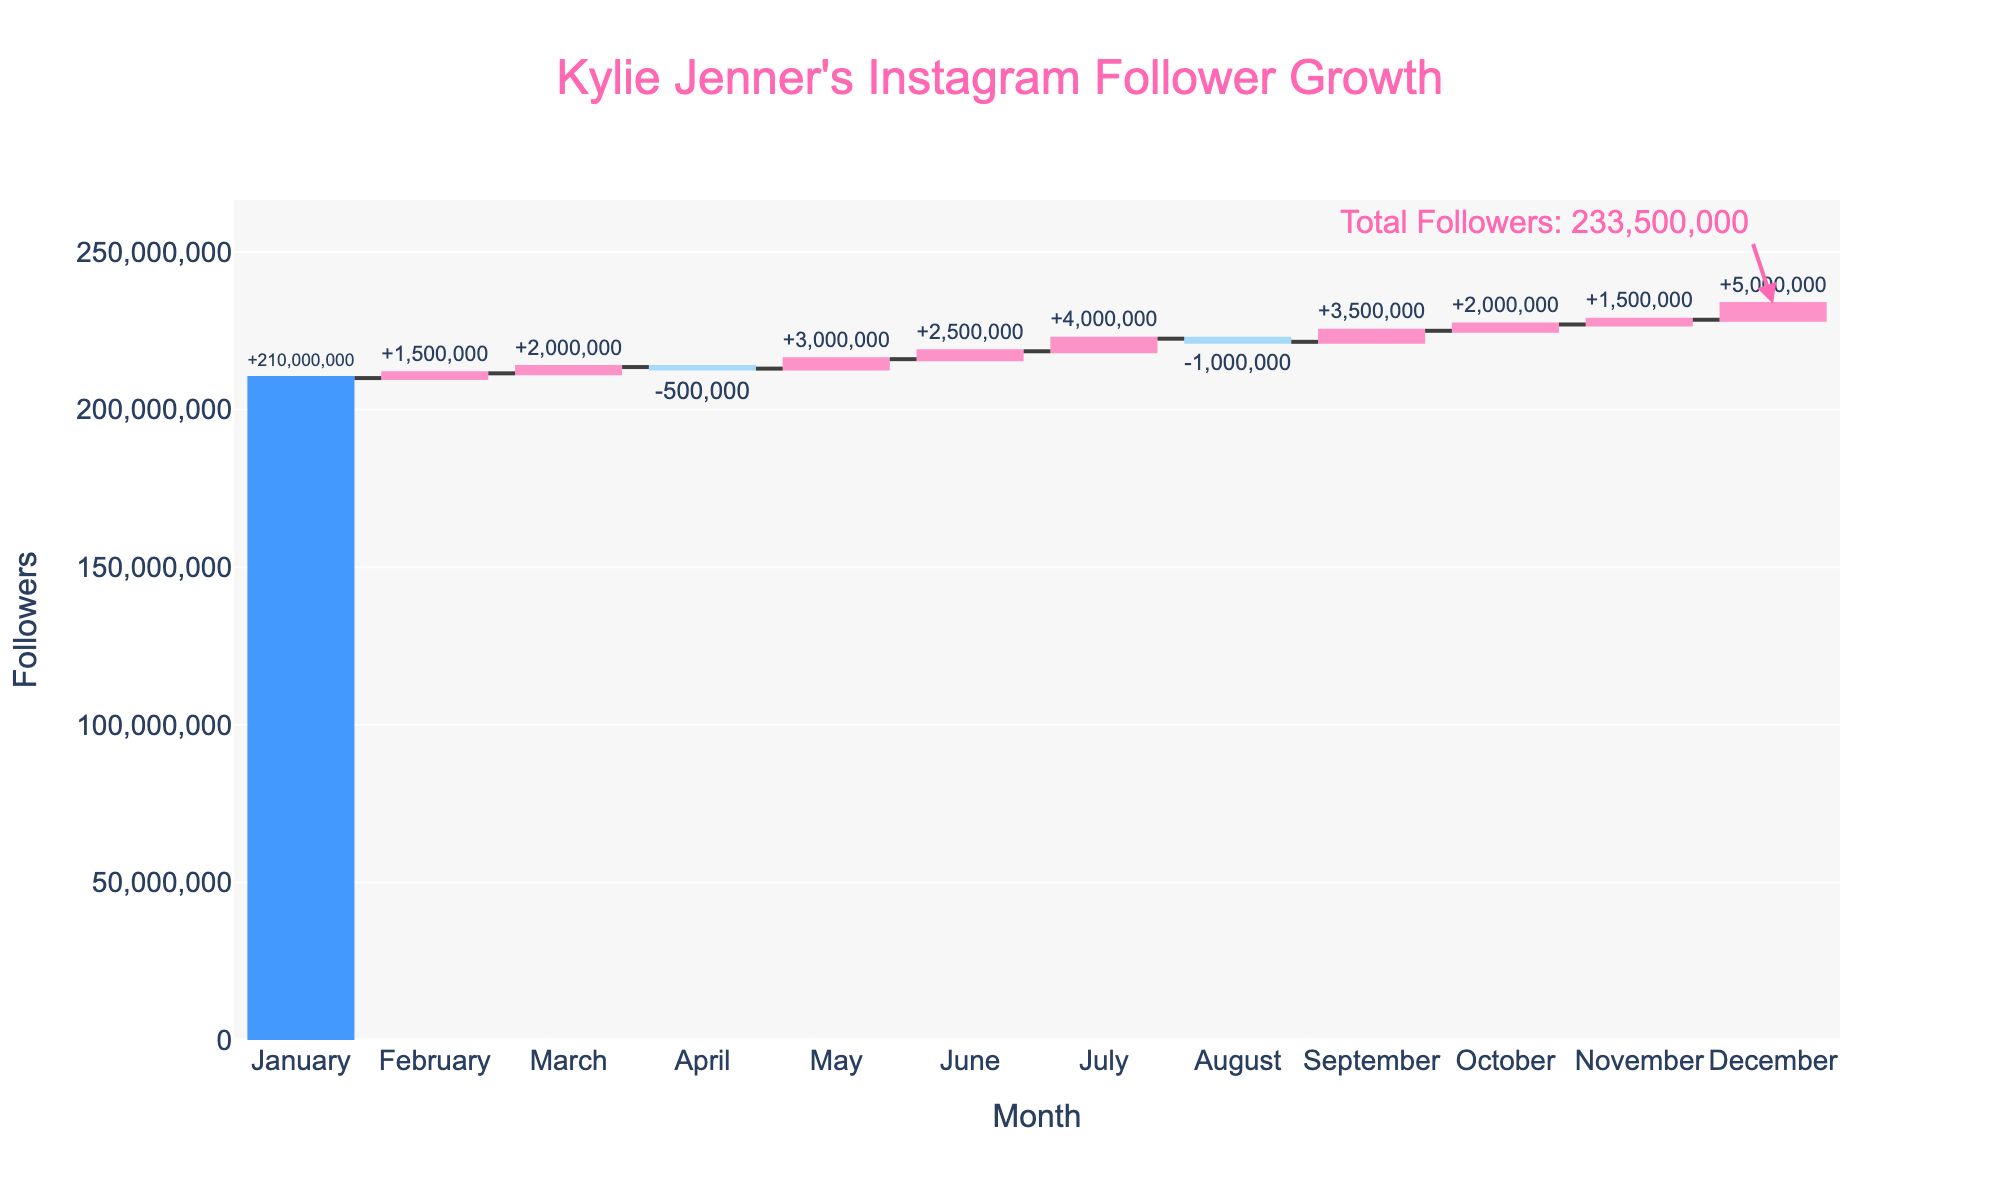what is the total number of followers Kylie Jenner had at the end of the year? At the end of December, we look at the cumulative sum of followers reached. Including the positive and negative changes throughout the year, she had a total of 210,000,000 (initial) + the sum of all monthly changes (1500000 + 2000000 - 500000 + 3000000 + 2500000 + 4000000 - 1000000 + 3500000 + 2000000 + 1500000 + 5000000)
Answer: 225,000,000 what month shows a decrease in Kylie’s followers, and how much was the decrease? Looking at the monthly changes in the figure, April and August show a negative change with reductions of 500,000 and 1,000,000 followers, respectively.
Answer: April and August, 500,000 and 1,000,000 what is the total gain in followers over the year, ignoring losses? We sum up the positive changes in the number of followers: 1,500,000 (Feb) + 2,000,000 (Mar) + 3,000,000 (May) + 2,500,000 (Jun) + 4,000,000 (Jul) + 3,500,000 (Sep) + 2,000,000 (Oct) + 1,500,000 (Nov) + 5,000,000 (Dec) = 24,500,000
Answer: 24,500,000 which month had the highest increase in followers? By examining the figure's bars, the largest increase is in December with a surge of 5,000,000 followers.
Answer: December how much did Kylie’s follower count change between January and July? The initial count in January is 210,000,000. By adding the changes until July 210,000,000 (initial) + 1,500,000 + 2,000,000 - 500,000 + 3,000,000 + 2,500,000 + 4,000,000, we find the count in July to be 222,500,000. The change is 222,500,000 - 210,000,000 = 12,500,000
Answer: 12,500,000 during which month did Kylie Jenner experience the smallest follower increase and what was the increase? The smallest positive change observed on the chart is in February with an increase of 1,500,000 followers.
Answer: February, 1,500,000 comparing July and September, which month had a greater increase in followers and by how much? July saw an increase of 4,000,000 followers and September 3,500,000 followers. 4,000,000 - 3,500,000 = 500,000, thus July had 500,000 more followers gained.
Answer: July, 500,000 how much did Kylie’s followers increase or decrease in months showing a loss? We sum the losses shown in April and August: -500,000 (April) + -1,000,000 (August) = -1,500,000
Answer: -1,500,000 if Kylie’s followers had followed the same trend in every month of the year, what would be the average monthly change? The total yearly change (sum of all monthly changes) is 15,000,000. There are 12 months, so the average monthly change is 15,000,000 / 12 = 1,250,000
Answer: 1,250,000 